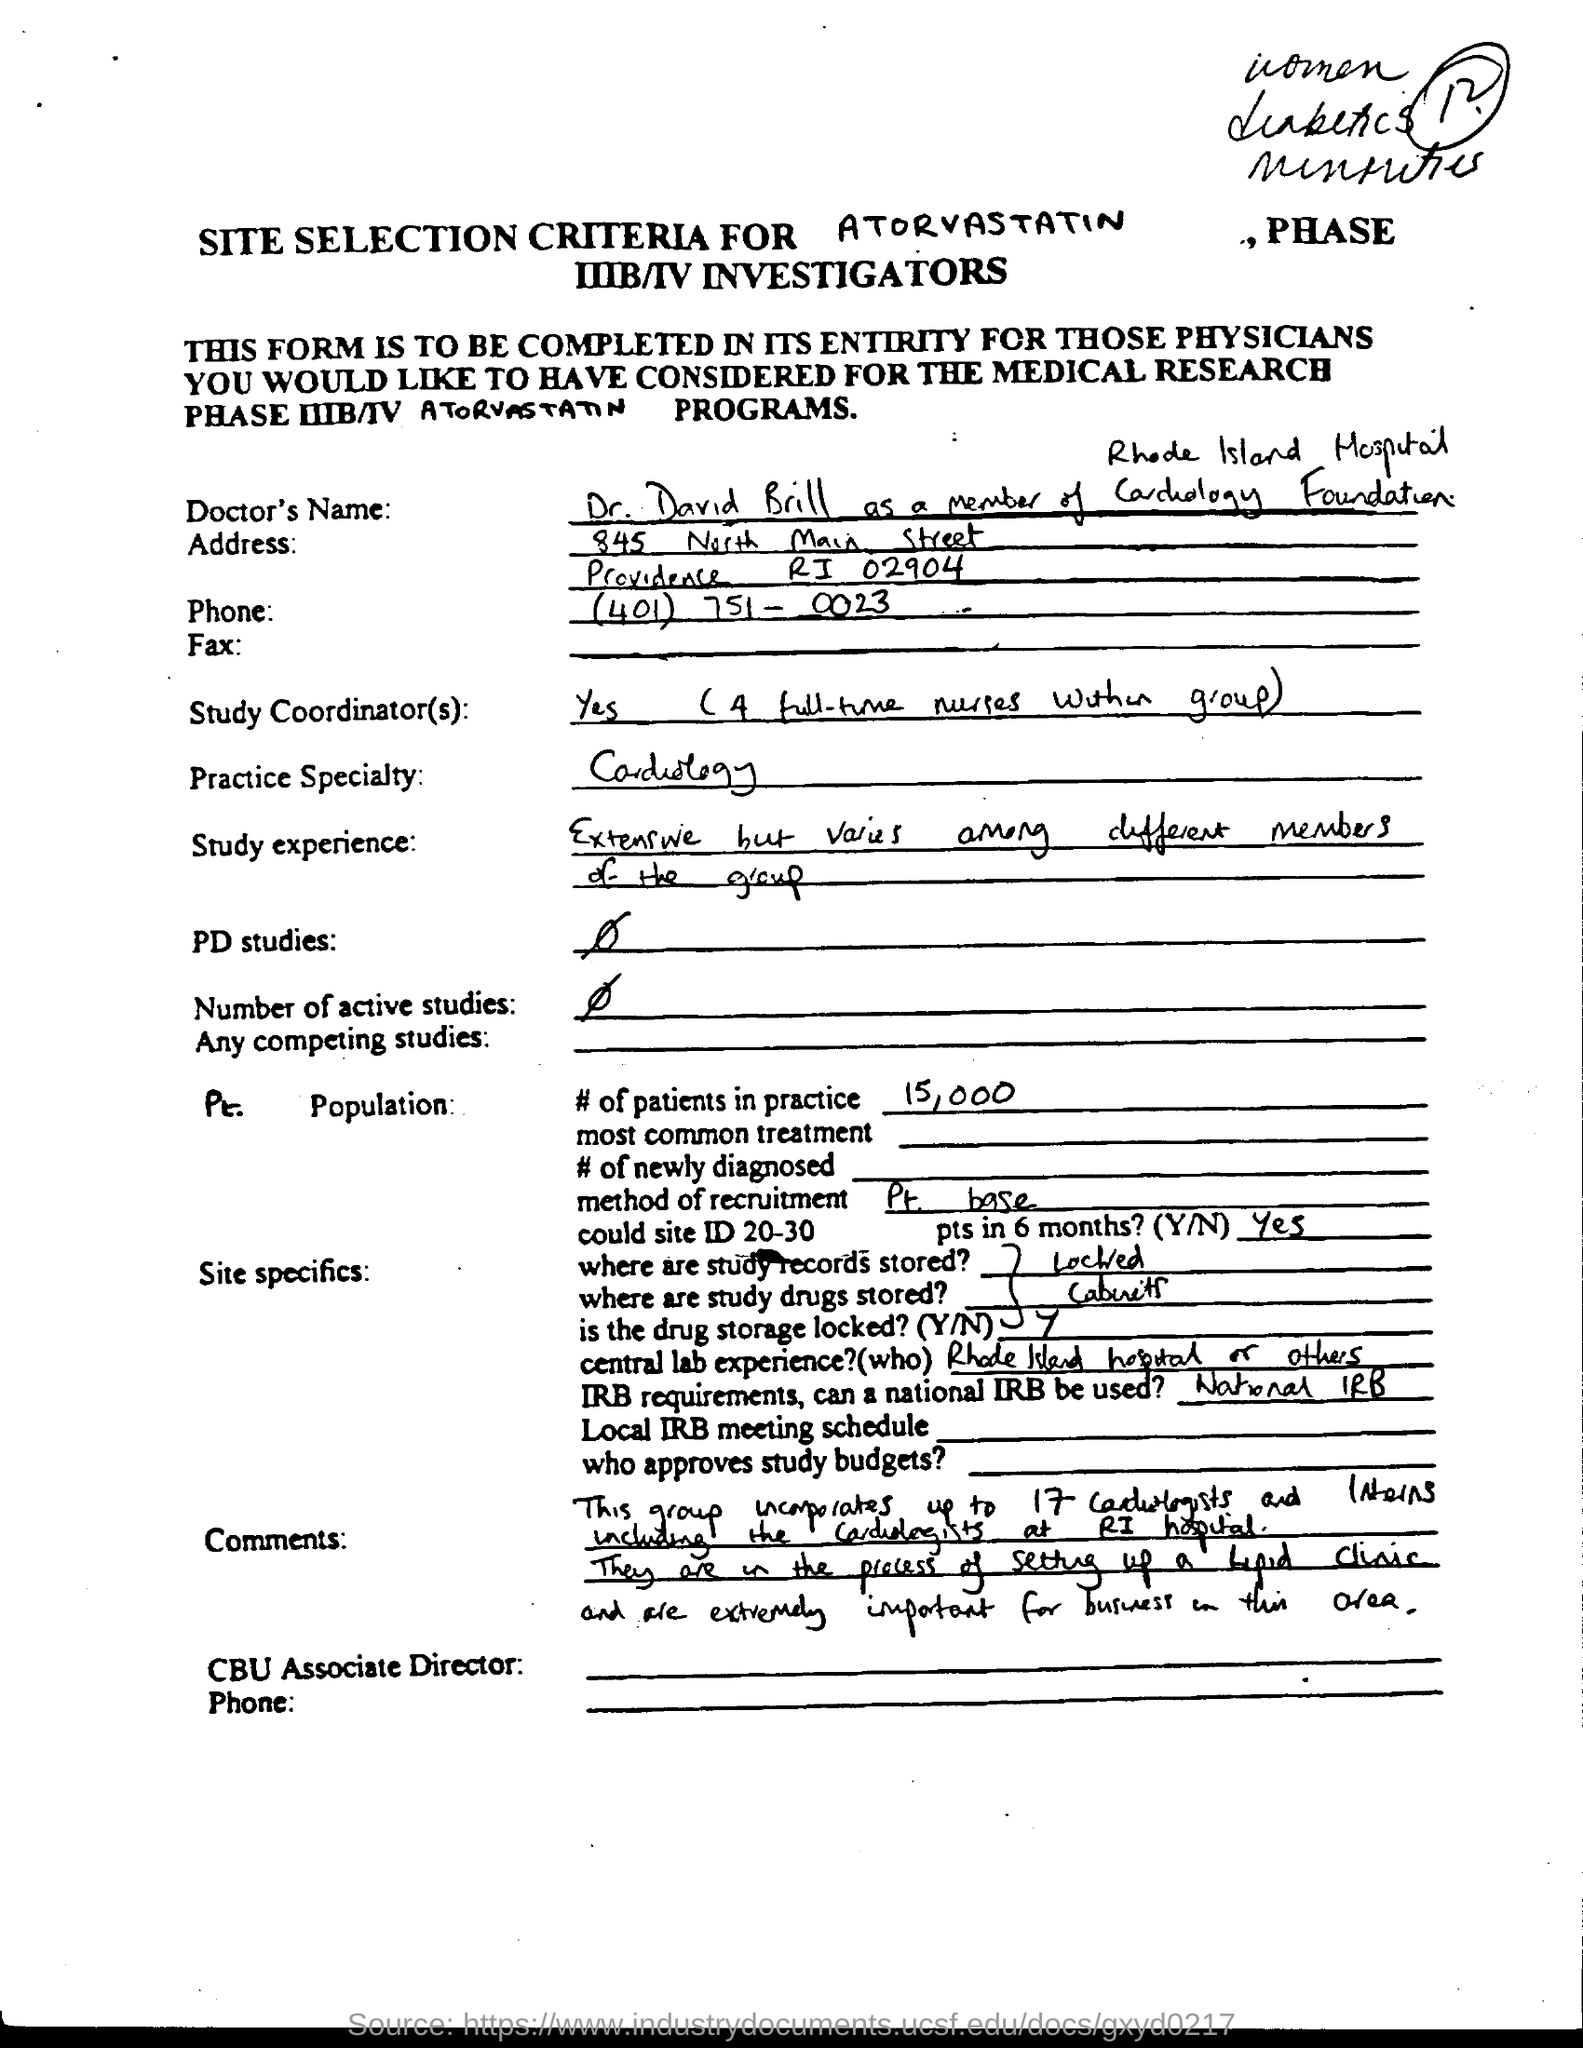Outline some significant characteristics in this image. The number of patients in the practice is 15,000. Please indicate whether the drug storage is locked or unlocked (Y/N). The method of recruitment for Part-time Bases employees is... Cardiology is my area of expertise and focus in practice. The Doctor's name is Dr. David Brill. 